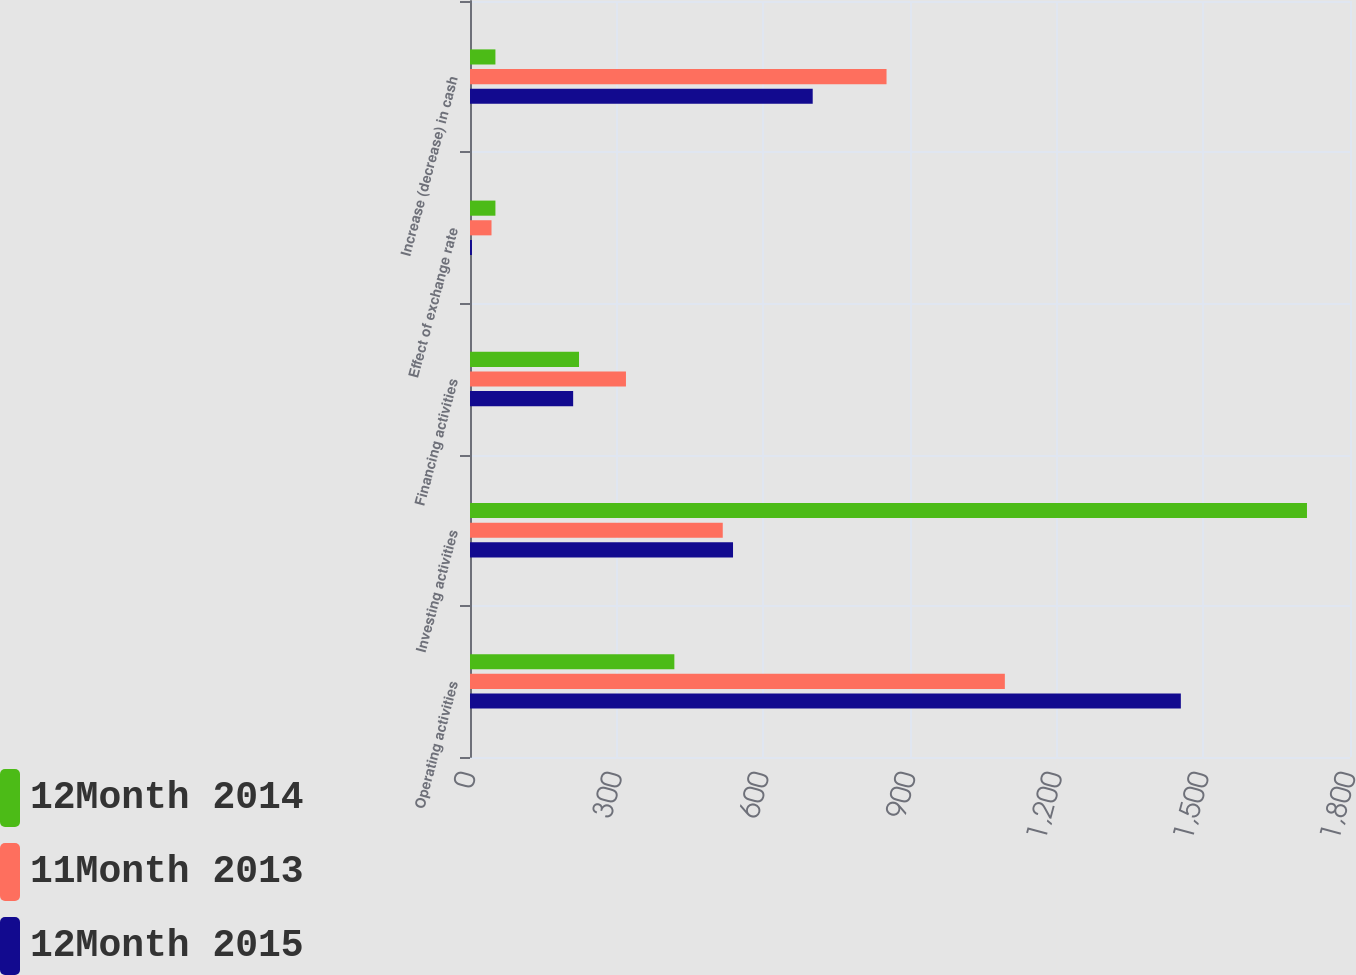Convert chart. <chart><loc_0><loc_0><loc_500><loc_500><stacked_bar_chart><ecel><fcel>Operating activities<fcel>Investing activities<fcel>Financing activities<fcel>Effect of exchange rate<fcel>Increase (decrease) in cash<nl><fcel>12Month 2014<fcel>418<fcel>1712<fcel>223<fcel>52<fcel>52<nl><fcel>11Month 2013<fcel>1094<fcel>517<fcel>319<fcel>44<fcel>852<nl><fcel>12Month 2015<fcel>1454<fcel>538<fcel>211<fcel>4<fcel>701<nl></chart> 